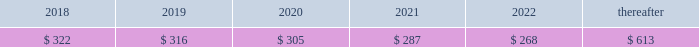92 | 2017 form 10-k finite-lived intangible assets are amortized over their estimated useful lives and tested for impairment if events or changes in circumstances indicate that the asset may be impaired .
In 2016 , gross customer relationship intangibles of $ 96 million and related accumulated amortization of $ 27 million as well as gross intellectual property intangibles of $ 111 million and related accumulated amortization of $ 48 million from the resource industries segment were impaired .
The fair value of these intangibles was determined to be insignificant based on an income approach using expected cash flows .
The fair value determination is categorized as level 3 in the fair value hierarchy due to its use of internal projections and unobservable measurement inputs .
The total impairment of $ 132 million was a result of restructuring activities and is included in other operating ( income ) expense in statement 1 .
See note 25 for information on restructuring costs .
Amortization expense related to intangible assets was $ 323 million , $ 326 million and $ 337 million for 2017 , 2016 and 2015 , respectively .
As of december 31 , 2017 , amortization expense related to intangible assets is expected to be : ( millions of dollars ) .
Goodwill there were no goodwill impairments during 2017 or 2015 .
Our annual impairment tests completed in the fourth quarter of 2016 indicated the fair value of each reporting unit was substantially above its respective carrying value , including goodwill , with the exception of our surface mining & technology reporting unit .
The surface mining & technology reporting unit , which primarily serves the mining industry , is a part of our resource industries segment .
The goodwill assigned to this reporting unit is largely from our acquisition of bucyrus international , inc .
In 2011 .
Its product portfolio includes large mining trucks , electric rope shovels , draglines , hydraulic shovels and related parts .
In addition to equipment , surface mining & technology also develops and sells technology products and services to provide customer fleet management , equipment management analytics and autonomous machine capabilities .
The annual impairment test completed in the fourth quarter of 2016 indicated that the fair value of surface mining & technology was below its carrying value requiring the second step of the goodwill impairment test process .
The fair value of surface mining & technology was determined primarily using an income approach based on a discounted ten year cash flow .
We assigned the fair value to surface mining & technology 2019s assets and liabilities using various valuation techniques that required assumptions about royalty rates , dealer attrition , technological obsolescence and discount rates .
The resulting implied fair value of goodwill was below the carrying value .
Accordingly , we recognized a goodwill impairment charge of $ 595 million , which resulted in goodwill of $ 629 million remaining for surface mining & technology as of october 1 , 2016 .
The fair value determination is categorized as level 3 in the fair value hierarchy due to its use of internal projections and unobservable measurement inputs .
There was a $ 17 million tax benefit associated with this impairment charge. .
What is the expected growth rate in amortization expense in 2017? 
Computations: ((323 - 326) / 326)
Answer: -0.0092. 